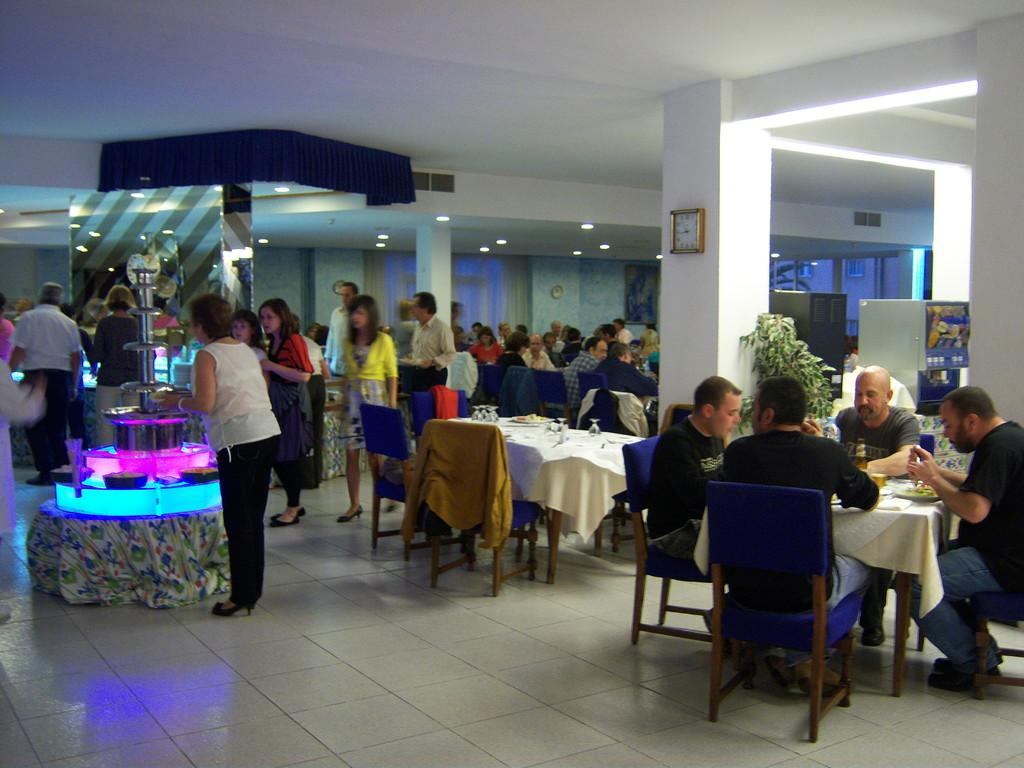How many people are in the group in the image? There is a group of people in the image, but the exact number is not specified. What are some of the people in the group doing? Some people in the group are sitting, while others are standing. What can be seen on the wall in the image? There is a clock on the wall in the image. What type of vegetation is present in the image? There is a plant in the image. What type of wine is being served at the event in the image? There is no event or wine present in the image; it features a group of people with some sitting and standing, a clock on the wall, and a plant. 